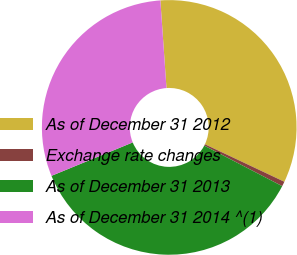Convert chart to OTSL. <chart><loc_0><loc_0><loc_500><loc_500><pie_chart><fcel>As of December 31 2012<fcel>Exchange rate changes<fcel>As of December 31 2013<fcel>As of December 31 2014 ^(1)<nl><fcel>33.13%<fcel>0.61%<fcel>36.16%<fcel>30.1%<nl></chart> 